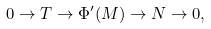Convert formula to latex. <formula><loc_0><loc_0><loc_500><loc_500>0 \to T \to \Phi ^ { \prime } ( M ) \to N \to 0 ,</formula> 